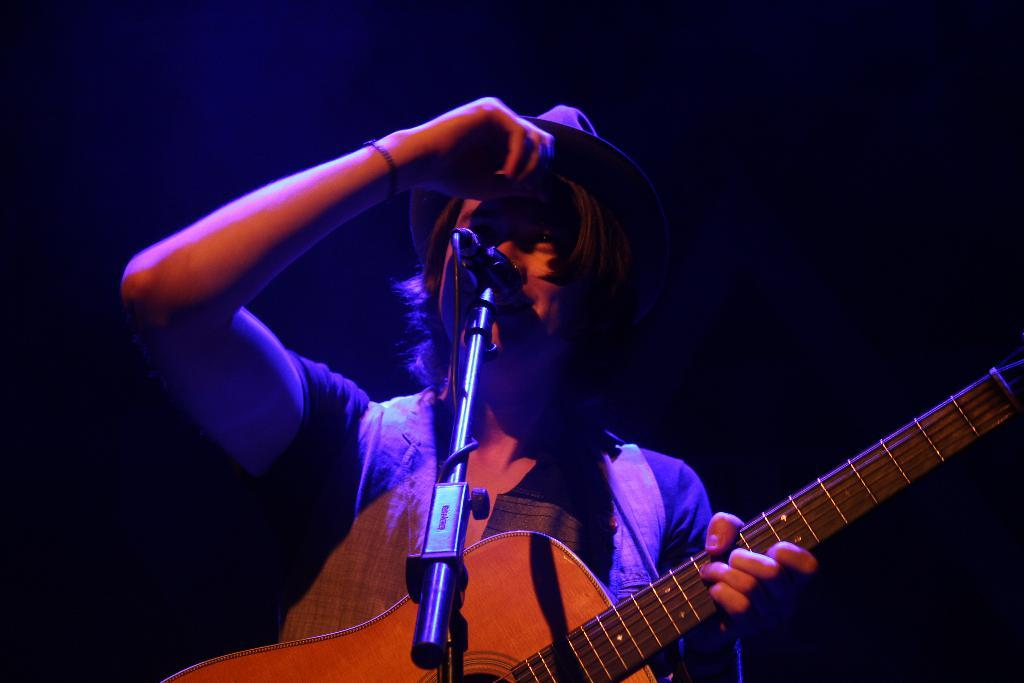What is the person in the image doing? The person is singing. What object is the person holding in the image? The person is holding a guitar. What can be seen in front of the person in the image? The person is standing in front of a microphone. What type of knee injury is the person experiencing in the image? There is no indication of a knee injury in the image; the person is singing and holding a guitar. What type of facial expression does the person have in the image? The provided facts do not mention the person's facial expression. 